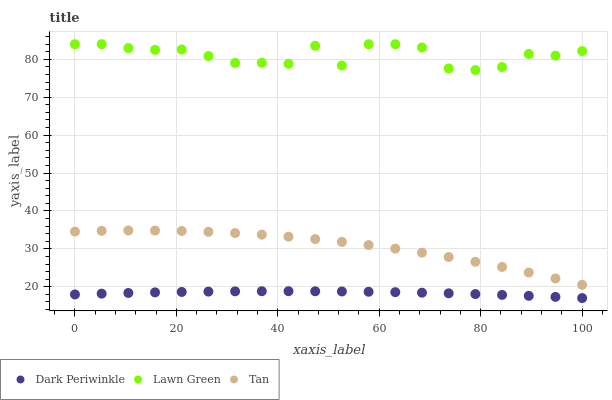Does Dark Periwinkle have the minimum area under the curve?
Answer yes or no. Yes. Does Lawn Green have the maximum area under the curve?
Answer yes or no. Yes. Does Tan have the minimum area under the curve?
Answer yes or no. No. Does Tan have the maximum area under the curve?
Answer yes or no. No. Is Dark Periwinkle the smoothest?
Answer yes or no. Yes. Is Lawn Green the roughest?
Answer yes or no. Yes. Is Tan the smoothest?
Answer yes or no. No. Is Tan the roughest?
Answer yes or no. No. Does Dark Periwinkle have the lowest value?
Answer yes or no. Yes. Does Tan have the lowest value?
Answer yes or no. No. Does Lawn Green have the highest value?
Answer yes or no. Yes. Does Tan have the highest value?
Answer yes or no. No. Is Tan less than Lawn Green?
Answer yes or no. Yes. Is Lawn Green greater than Dark Periwinkle?
Answer yes or no. Yes. Does Tan intersect Lawn Green?
Answer yes or no. No. 